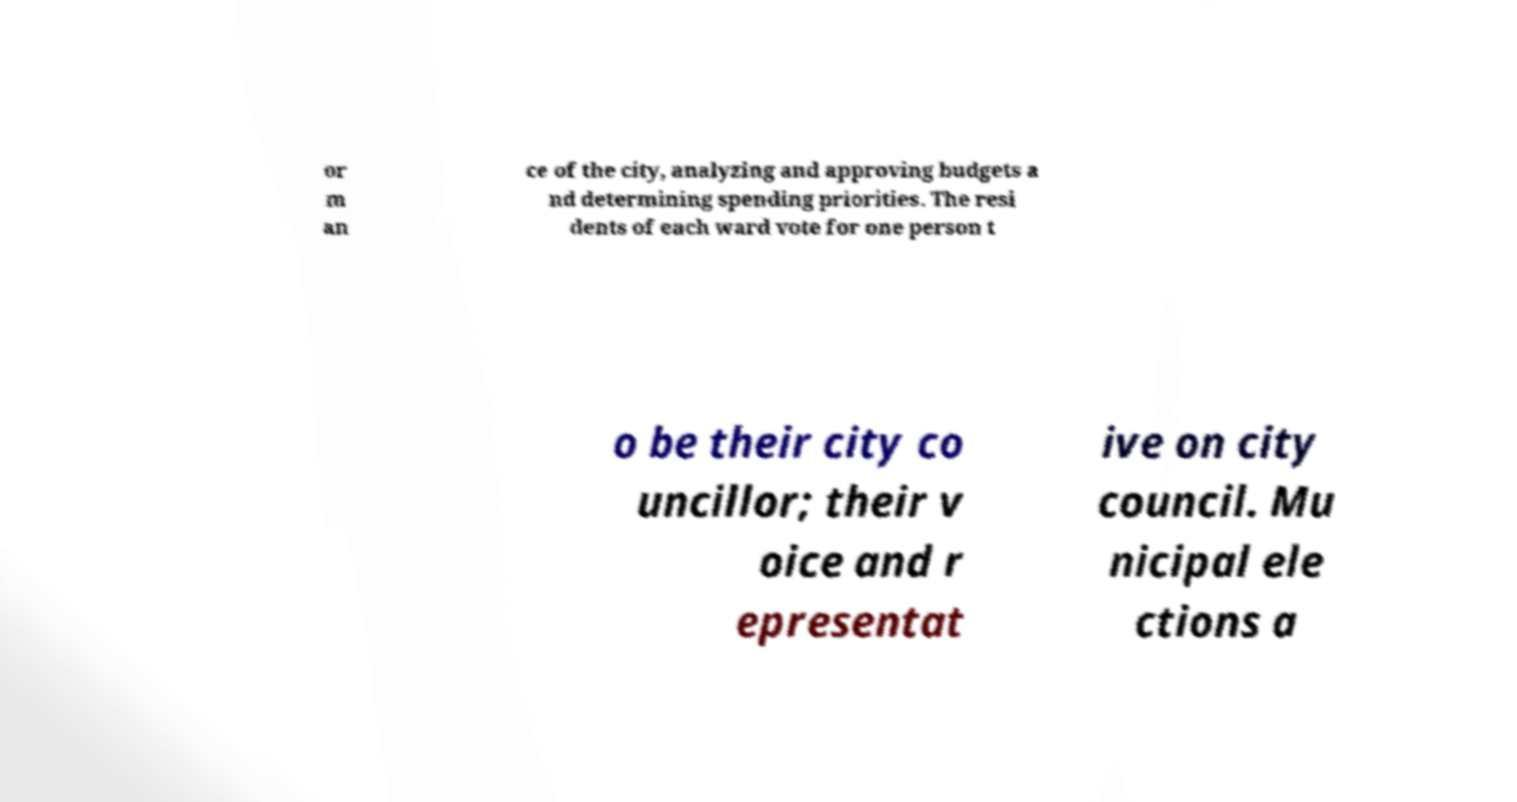For documentation purposes, I need the text within this image transcribed. Could you provide that? or m an ce of the city, analyzing and approving budgets a nd determining spending priorities. The resi dents of each ward vote for one person t o be their city co uncillor; their v oice and r epresentat ive on city council. Mu nicipal ele ctions a 